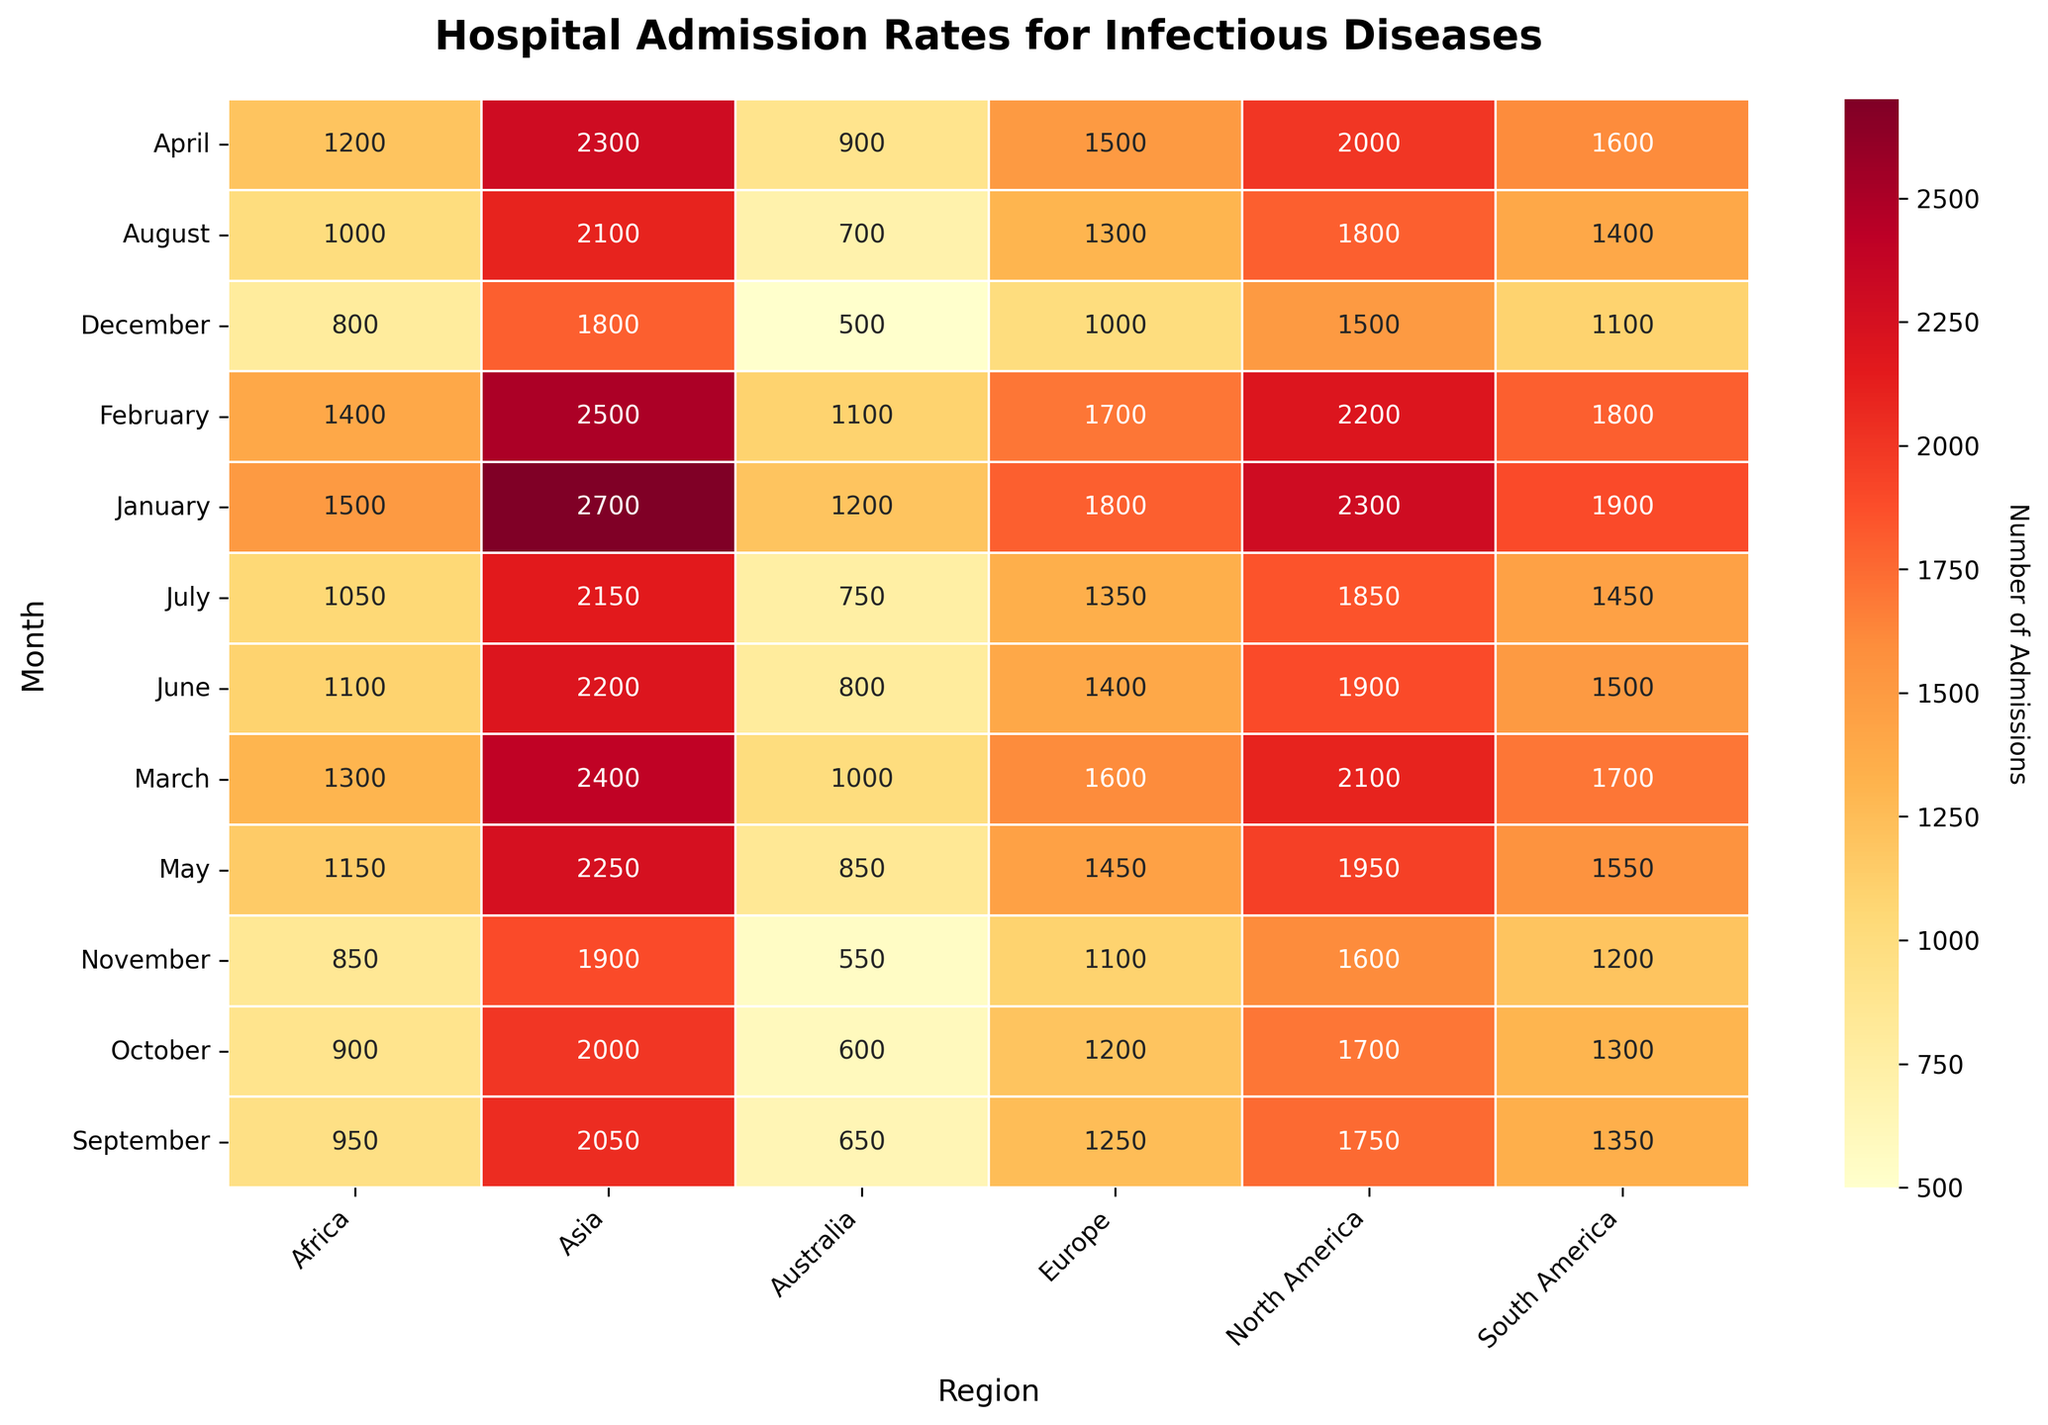What is the title of the heatmap? Look at the top of the heatmap where the title is prominently displayed in a larger and bold font.
Answer: Hospital Admission Rates for Infectious Diseases Which month and region have the highest hospital admission rates? Scan through the heatmap and identify the cell with the darkest red color, then cross-reference to find the corresponding month and region.
Answer: January, Asia What is the hospital admission rate for Infectious Diseases in Africa during April? Locate the cell corresponding to Africa on the x-axis and April on the y-axis and read the value displayed in the cell.
Answer: 1200 In which month does North America have its lowest hospital admission rate? Scan the row corresponding to North America and look for the smallest value.
Answer: December Which region has the most consistent hospital admission rates throughout the year? Compare the range or variance of the admission rates for each region by scanning through the vertical columns.
Answer: Australia What is the difference in hospital admission rates between January and December in Asia? Identify the values for January and December in the Asia column, then subtract the December value from the January value (2700 - 1800).
Answer: 900 Which month sees the smallest difference in admission rates across all regions? Compare the difference between the highest and lowest values for each month by looking at each row of the heatmap.
Answer: August How does the admission rate in Europe change from May to November? Find the admission rates for Europe in May and November and subtract the November value from the May value (1450 - 1100).
Answer: It decreases by 350 Which region has the maximum hospital admissions in February? Scan the February row and identify the region with the darkest color cell, corresponding to the highest value.
Answer: Asia What is the average hospital admission rate in South America over the year? Add up the hospital admissions for South America for all the months and divide by 12 (1900 + 1800 + 1700 + 1600 + 1550 + 1500 + 1450 + 1400 + 1350 + 1300 + 1200 + 1100 = 18850, then divide by 12).
Answer: 1570.83 